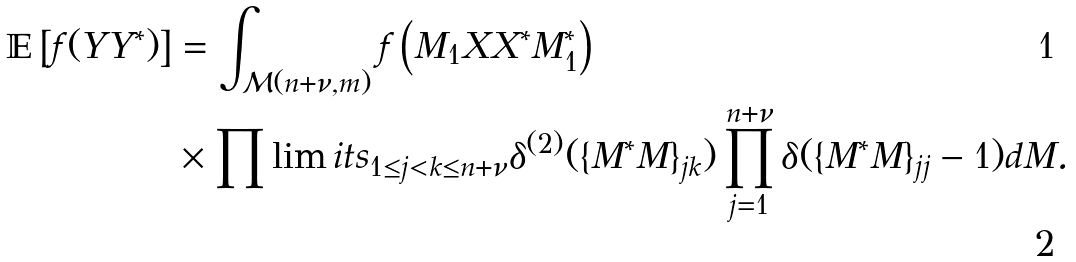<formula> <loc_0><loc_0><loc_500><loc_500>\mathbb { E } \left [ f ( Y Y ^ { * } ) \right ] & = \int _ { \mathcal { M } ( n + \nu , m ) } f \left ( M _ { 1 } X X ^ { * } M _ { 1 } ^ { * } \right ) \\ & \times \prod \lim i t s _ { 1 \leq j < k \leq n + \nu } \delta ^ { ( 2 ) } ( \{ M ^ { * } M \} _ { j k } ) \prod _ { j = 1 } ^ { n + \nu } \delta ( \{ M ^ { * } M \} _ { j j } - 1 ) d M .</formula> 